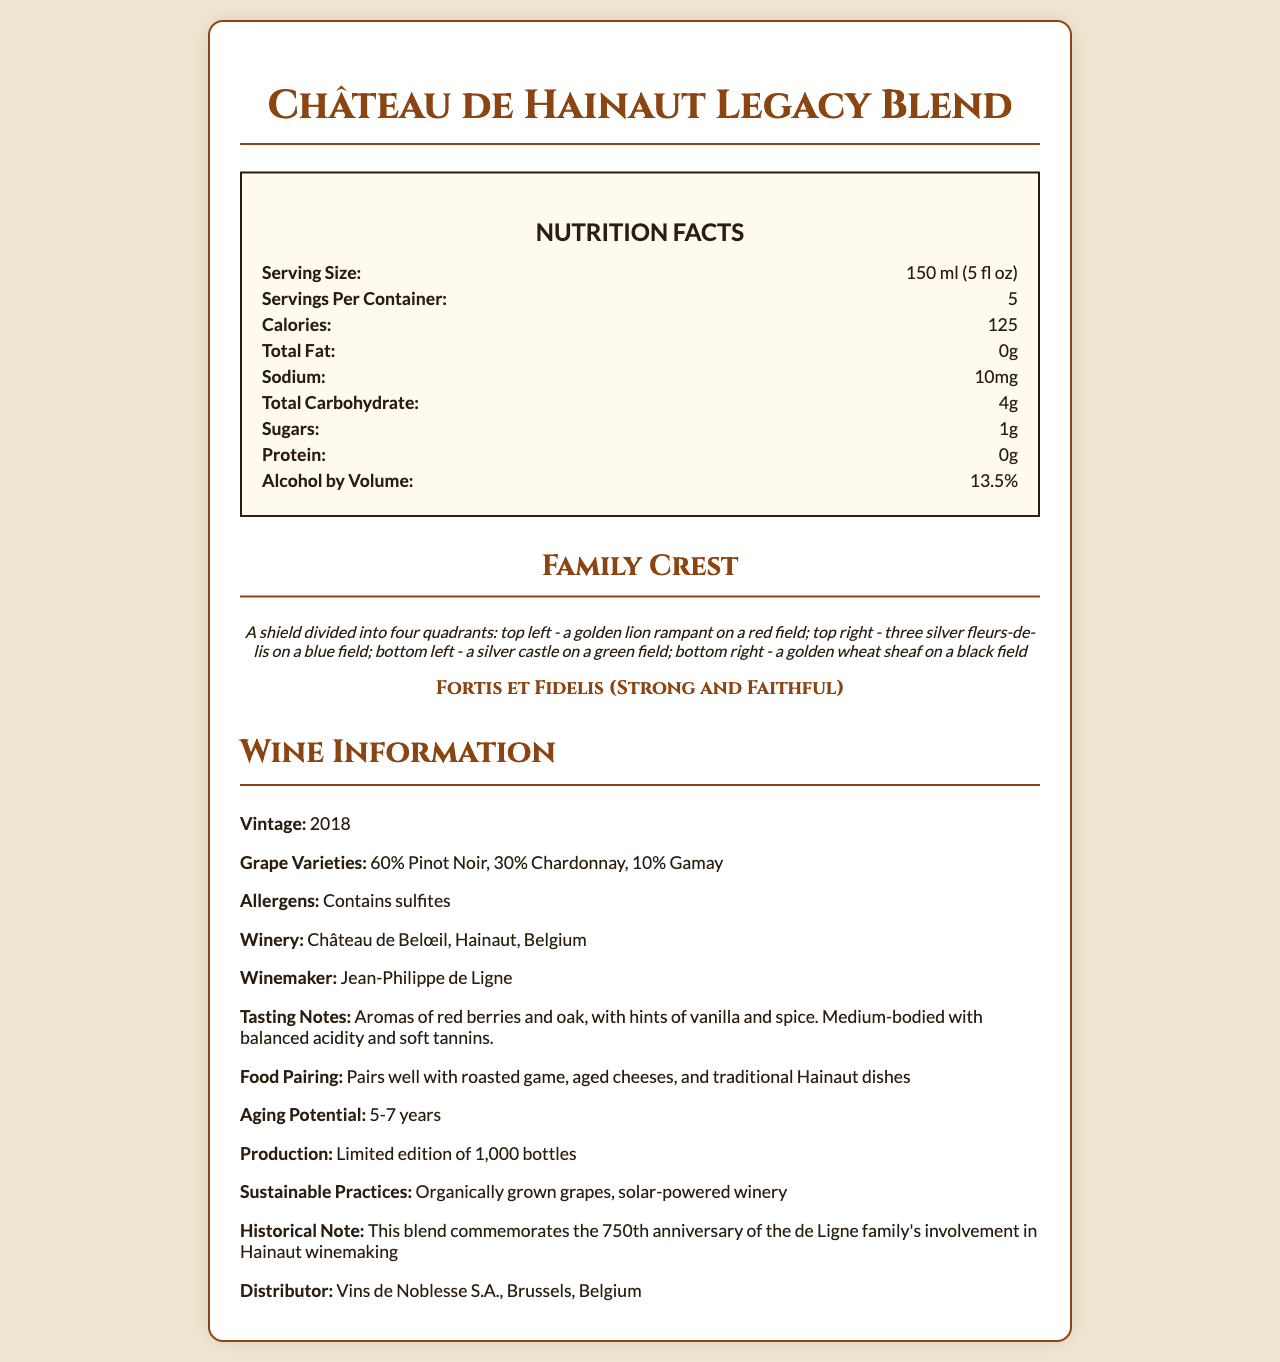what is the serving size? The serving size is explicitly stated under the "Nutrition Facts" section in the document.
Answer: 150 ml (5 fl oz) how many calories are in a serving? It is mentioned under the "Nutrition Facts" next to the label "Calories".
Answer: 125 what is the amount of total fat in this wine blend? The "Nutrition Facts" section lists the total fat content as 0 grams.
Answer: 0g how many grams of sugars are in one serving? The "Nutrition Facts" section specifies that there is 1 gram of sugars per serving.
Answer: 1g who is the winemaker? The winemaker is listed under the "Wine Information" section.
Answer: Jean-Philippe de Ligne what percentage of the blend is Pinot Noir? A. 30% B. 10% C. 60% D. 15% The document states "60% Pinot Noir" under the "Wine Information" section in grape varieties.
Answer: C what symbol is in the top right quadrant of the family crest? A. Golden lion B. Three silver fleurs-de-lis C. Silver castle D. Golden wheat sheaf The family crest description mentions three silver fleurs-de-lis on a blue field in the top right quadrant.
Answer: B is the wine blend aged to last more than 5 years? The "Wine Information" section under aging potential states "5-7 years", which means it can be aged for more than 5 years.
Answer: Yes describe the main nutritional components and additional features of the "Château de Hainaut Legacy Blend" This summary encompasses all the essential nutritional facts, family crest description, wine information, and notable features from the document.
Answer: The "Château de Hainaut Legacy Blend" is a wine with a serving size of 150 ml (5 fl oz) and 125 calories per serving. It contains 0g total fat, 10mg sodium, 4g total carbohydrates, 1g sugars, 0g protein, and an alcohol by volume of 13.5%. The family crest features a golden lion, silver fleurs-de-lis, a silver castle, and a golden wheat sheaf. The wine is a 2018 vintage blend of Pinot Noir, Chardonnay, and Gamay, produced by Jean-Philippe de Ligne at Château de Belœil in Hainaut, Belgium. The wine is sustainable, has a limited edition of 1,000 bottles, and pairs well with traditional dishes. how many bottles were produced for this wine blend? The production quantity is mentioned under "Wine Information" as a limited edition of 1,000 bottles.
Answer: 1,000 what is the historical significance mentioned for this wine blend? The historical note in the "Wine Information" section describes this commemoration.
Answer: It commemorates the 750th anniversary of the de Ligne family's involvement in Hainaut winemaking. how many carbohydrates does a full container contain? Since each serving contains 4g and there are 5 servings per container, multiplying 4g by 5 gives 20g.
Answer: 20g what sustainable practices are employed for this wine? Both practices are listed in the "Sustainable Practices" section under "Wine Information".
Answer: Organically grown grapes, solar-powered winery what is the distributor of the wine? The distributor's information is provided under the "Distributor" label in the "Wine Information" section.
Answer: Vins de Noblesse S.A., Brussels, Belgium does the family crest feature any animals? The family crest includes a golden lion rampant, as described in the document.
Answer: Yes can this wine be consumed by someone with a sulfite allergy? The document mentions that the wine contains sulfites, which would not be suitable for someone with a sulfite allergy.
Answer: No what is the country of origin for this wine blend? The winery location is Château de Belœil in Hainaut, Belgium, which confirms the country of origin.
Answer: Belgium how many calories are in two servings of this wine blend? Since one serving contains 125 calories, multiplying by 2 gives 250 calories for two servings.
Answer: 250 are foods like roasted game and aged cheeses good pairings for this wine? The "Food Pairing" section suggests that this wine pairs well with roasted game, aged cheeses, and traditional Hainaut dishes.
Answer: True what is the packaging material of the wine bottle? The document does not provide any information about the material of the wine bottle's packaging.
Answer: Cannot be determined 